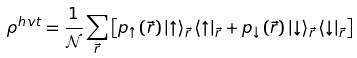Convert formula to latex. <formula><loc_0><loc_0><loc_500><loc_500>\rho ^ { h v t } = \frac { 1 } { \mathcal { N } } \sum _ { \vec { r } } \left [ p _ { \uparrow } \left ( \vec { r } \right ) \left | \uparrow \right > _ { \vec { r } } \left < \uparrow \right | _ { \vec { r } } + p _ { \downarrow } \left ( \vec { r } \right ) \left | \downarrow \right > _ { \vec { r } } \left < \downarrow \right | _ { \vec { r } } \right ]</formula> 